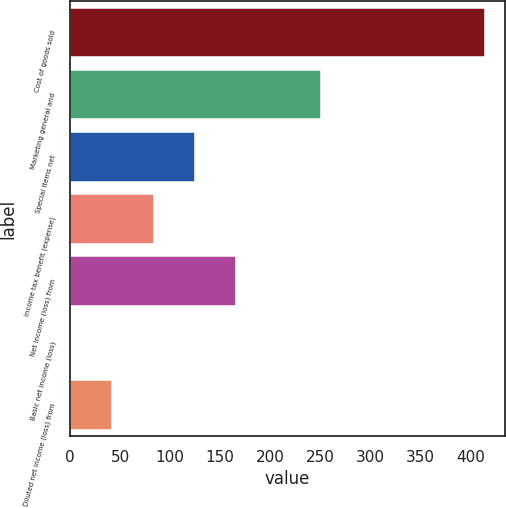Convert chart. <chart><loc_0><loc_0><loc_500><loc_500><bar_chart><fcel>Cost of goods sold<fcel>Marketing general and<fcel>Special items net<fcel>Income tax benefit (expense)<fcel>Net income (loss) from<fcel>Basic net income (loss)<fcel>Diluted net income (loss) from<nl><fcel>414<fcel>250.9<fcel>124.76<fcel>83.44<fcel>166.08<fcel>0.8<fcel>42.12<nl></chart> 